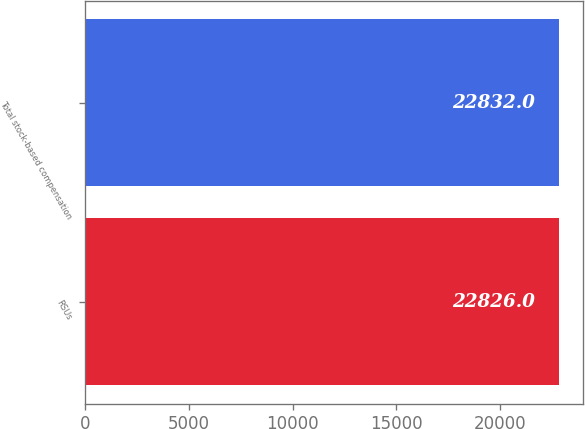Convert chart. <chart><loc_0><loc_0><loc_500><loc_500><bar_chart><fcel>RSUs<fcel>Total stock-based compensation<nl><fcel>22826<fcel>22832<nl></chart> 